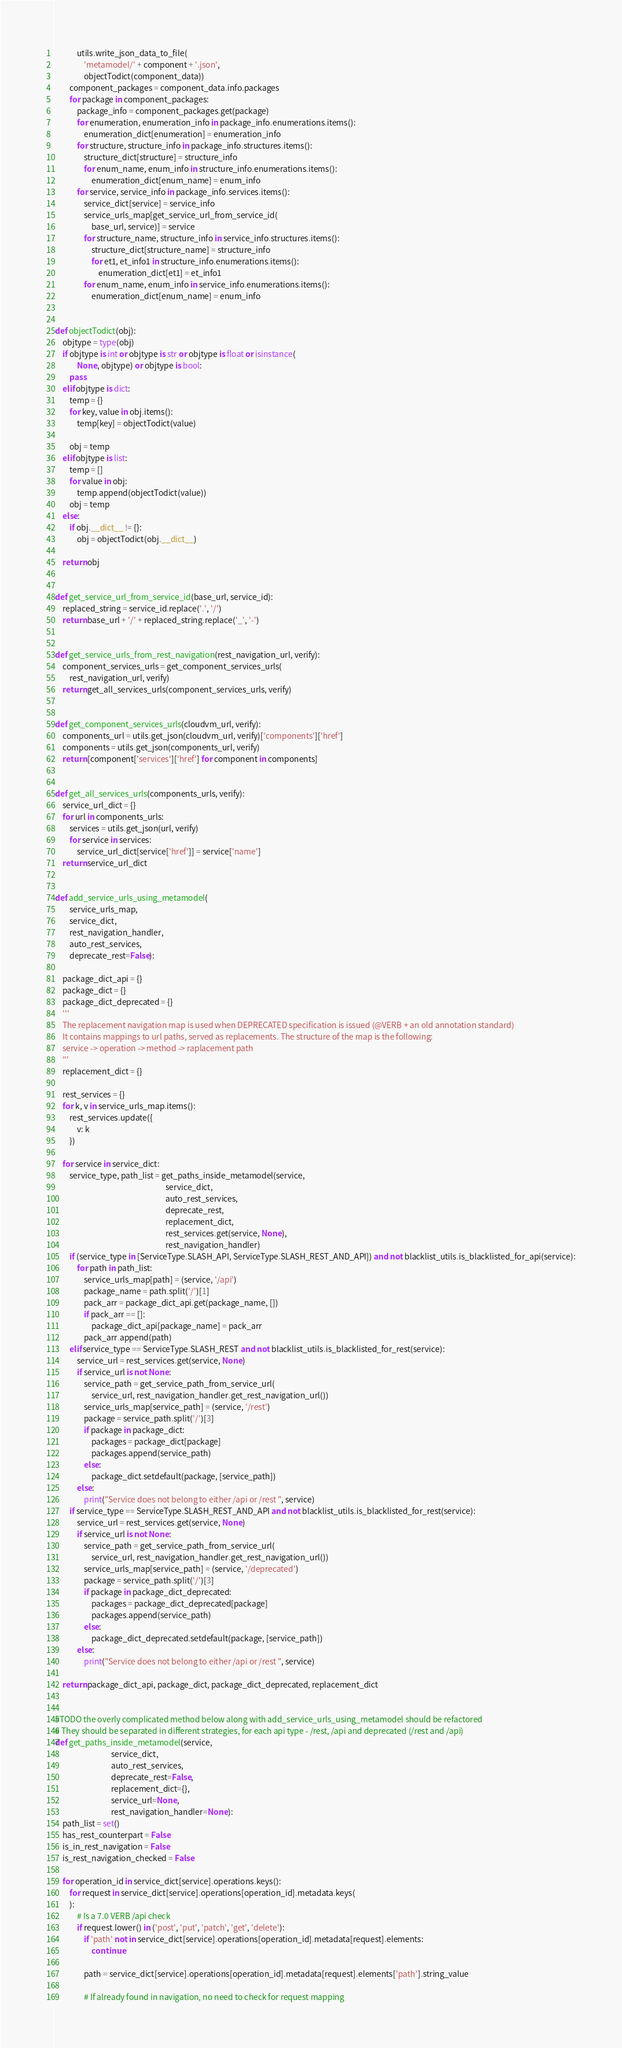Convert code to text. <code><loc_0><loc_0><loc_500><loc_500><_Python_>            utils.write_json_data_to_file(
                'metamodel/' + component + '.json',
                objectTodict(component_data))
        component_packages = component_data.info.packages
        for package in component_packages:
            package_info = component_packages.get(package)
            for enumeration, enumeration_info in package_info.enumerations.items():
                enumeration_dict[enumeration] = enumeration_info
            for structure, structure_info in package_info.structures.items():
                structure_dict[structure] = structure_info
                for enum_name, enum_info in structure_info.enumerations.items():
                    enumeration_dict[enum_name] = enum_info
            for service, service_info in package_info.services.items():
                service_dict[service] = service_info
                service_urls_map[get_service_url_from_service_id(
                    base_url, service)] = service
                for structure_name, structure_info in service_info.structures.items():
                    structure_dict[structure_name] = structure_info
                    for et1, et_info1 in structure_info.enumerations.items():
                        enumeration_dict[et1] = et_info1
                for enum_name, enum_info in service_info.enumerations.items():
                    enumeration_dict[enum_name] = enum_info


def objectTodict(obj):
    objtype = type(obj)
    if objtype is int or objtype is str or objtype is float or isinstance(
            None, objtype) or objtype is bool:
        pass
    elif objtype is dict:
        temp = {}
        for key, value in obj.items():
            temp[key] = objectTodict(value)

        obj = temp
    elif objtype is list:
        temp = []
        for value in obj:
            temp.append(objectTodict(value))
        obj = temp
    else:
        if obj.__dict__ != {}:
            obj = objectTodict(obj.__dict__)

    return obj


def get_service_url_from_service_id(base_url, service_id):
    replaced_string = service_id.replace('.', '/')
    return base_url + '/' + replaced_string.replace('_', '-')


def get_service_urls_from_rest_navigation(rest_navigation_url, verify):
    component_services_urls = get_component_services_urls(
        rest_navigation_url, verify)
    return get_all_services_urls(component_services_urls, verify)


def get_component_services_urls(cloudvm_url, verify):
    components_url = utils.get_json(cloudvm_url, verify)['components']['href']
    components = utils.get_json(components_url, verify)
    return [component['services']['href'] for component in components]


def get_all_services_urls(components_urls, verify):
    service_url_dict = {}
    for url in components_urls:
        services = utils.get_json(url, verify)
        for service in services:
            service_url_dict[service['href']] = service['name']
    return service_url_dict


def add_service_urls_using_metamodel(
        service_urls_map,
        service_dict,
        rest_navigation_handler,
        auto_rest_services,
        deprecate_rest=False):

    package_dict_api = {}
    package_dict = {}
    package_dict_deprecated = {}
    '''
    The replacement navigation map is used when DEPRECATED specification is issued (@VERB + an old annotation standard)
    It contains mappings to url paths, served as replacements. The structure of the map is the following: 
    service -> operation -> method -> raplacement path
    '''
    replacement_dict = {}

    rest_services = {}
    for k, v in service_urls_map.items():
        rest_services.update({
            v: k
        })

    for service in service_dict:
        service_type, path_list = get_paths_inside_metamodel(service,
                                                             service_dict,
                                                             auto_rest_services,
                                                             deprecate_rest,
                                                             replacement_dict,
                                                             rest_services.get(service, None),
                                                             rest_navigation_handler)
        if (service_type in [ServiceType.SLASH_API, ServiceType.SLASH_REST_AND_API]) and not blacklist_utils.is_blacklisted_for_api(service):
            for path in path_list:
                service_urls_map[path] = (service, '/api')
                package_name = path.split('/')[1]
                pack_arr = package_dict_api.get(package_name, [])
                if pack_arr == []:
                    package_dict_api[package_name] = pack_arr
                pack_arr.append(path)
        elif service_type == ServiceType.SLASH_REST and not blacklist_utils.is_blacklisted_for_rest(service):
            service_url = rest_services.get(service, None)
            if service_url is not None:
                service_path = get_service_path_from_service_url(
                    service_url, rest_navigation_handler.get_rest_navigation_url())
                service_urls_map[service_path] = (service, '/rest')
                package = service_path.split('/')[3]
                if package in package_dict:
                    packages = package_dict[package]
                    packages.append(service_path)
                else:
                    package_dict.setdefault(package, [service_path])
            else:
                print("Service does not belong to either /api or /rest ", service)
        if service_type == ServiceType.SLASH_REST_AND_API and not blacklist_utils.is_blacklisted_for_rest(service):
            service_url = rest_services.get(service, None)
            if service_url is not None:
                service_path = get_service_path_from_service_url(
                    service_url, rest_navigation_handler.get_rest_navigation_url())
                service_urls_map[service_path] = (service, '/deprecated')
                package = service_path.split('/')[3]
                if package in package_dict_deprecated:
                    packages = package_dict_deprecated[package]
                    packages.append(service_path)
                else:
                    package_dict_deprecated.setdefault(package, [service_path])
            else:
                print("Service does not belong to either /api or /rest ", service)

    return package_dict_api, package_dict, package_dict_deprecated, replacement_dict


#TODO the overly complicated method below along with add_service_urls_using_metamodel should be refactored
# They should be separated in different strategies, for each api type - /rest, /api and deprecated (/rest and /api)
def get_paths_inside_metamodel(service,
                               service_dict,
                               auto_rest_services,
                               deprecate_rest=False,
                               replacement_dict={},
                               service_url=None,
                               rest_navigation_handler=None):
    path_list = set()
    has_rest_counterpart = False
    is_in_rest_navigation = False
    is_rest_navigation_checked = False

    for operation_id in service_dict[service].operations.keys():
        for request in service_dict[service].operations[operation_id].metadata.keys(
        ):
            # Is a 7.0 VERB /api check
            if request.lower() in ('post', 'put', 'patch', 'get', 'delete'):
                if 'path' not in service_dict[service].operations[operation_id].metadata[request].elements:
                    continue

                path = service_dict[service].operations[operation_id].metadata[request].elements['path'].string_value

                # If already found in navigation, no need to check for request mapping</code> 